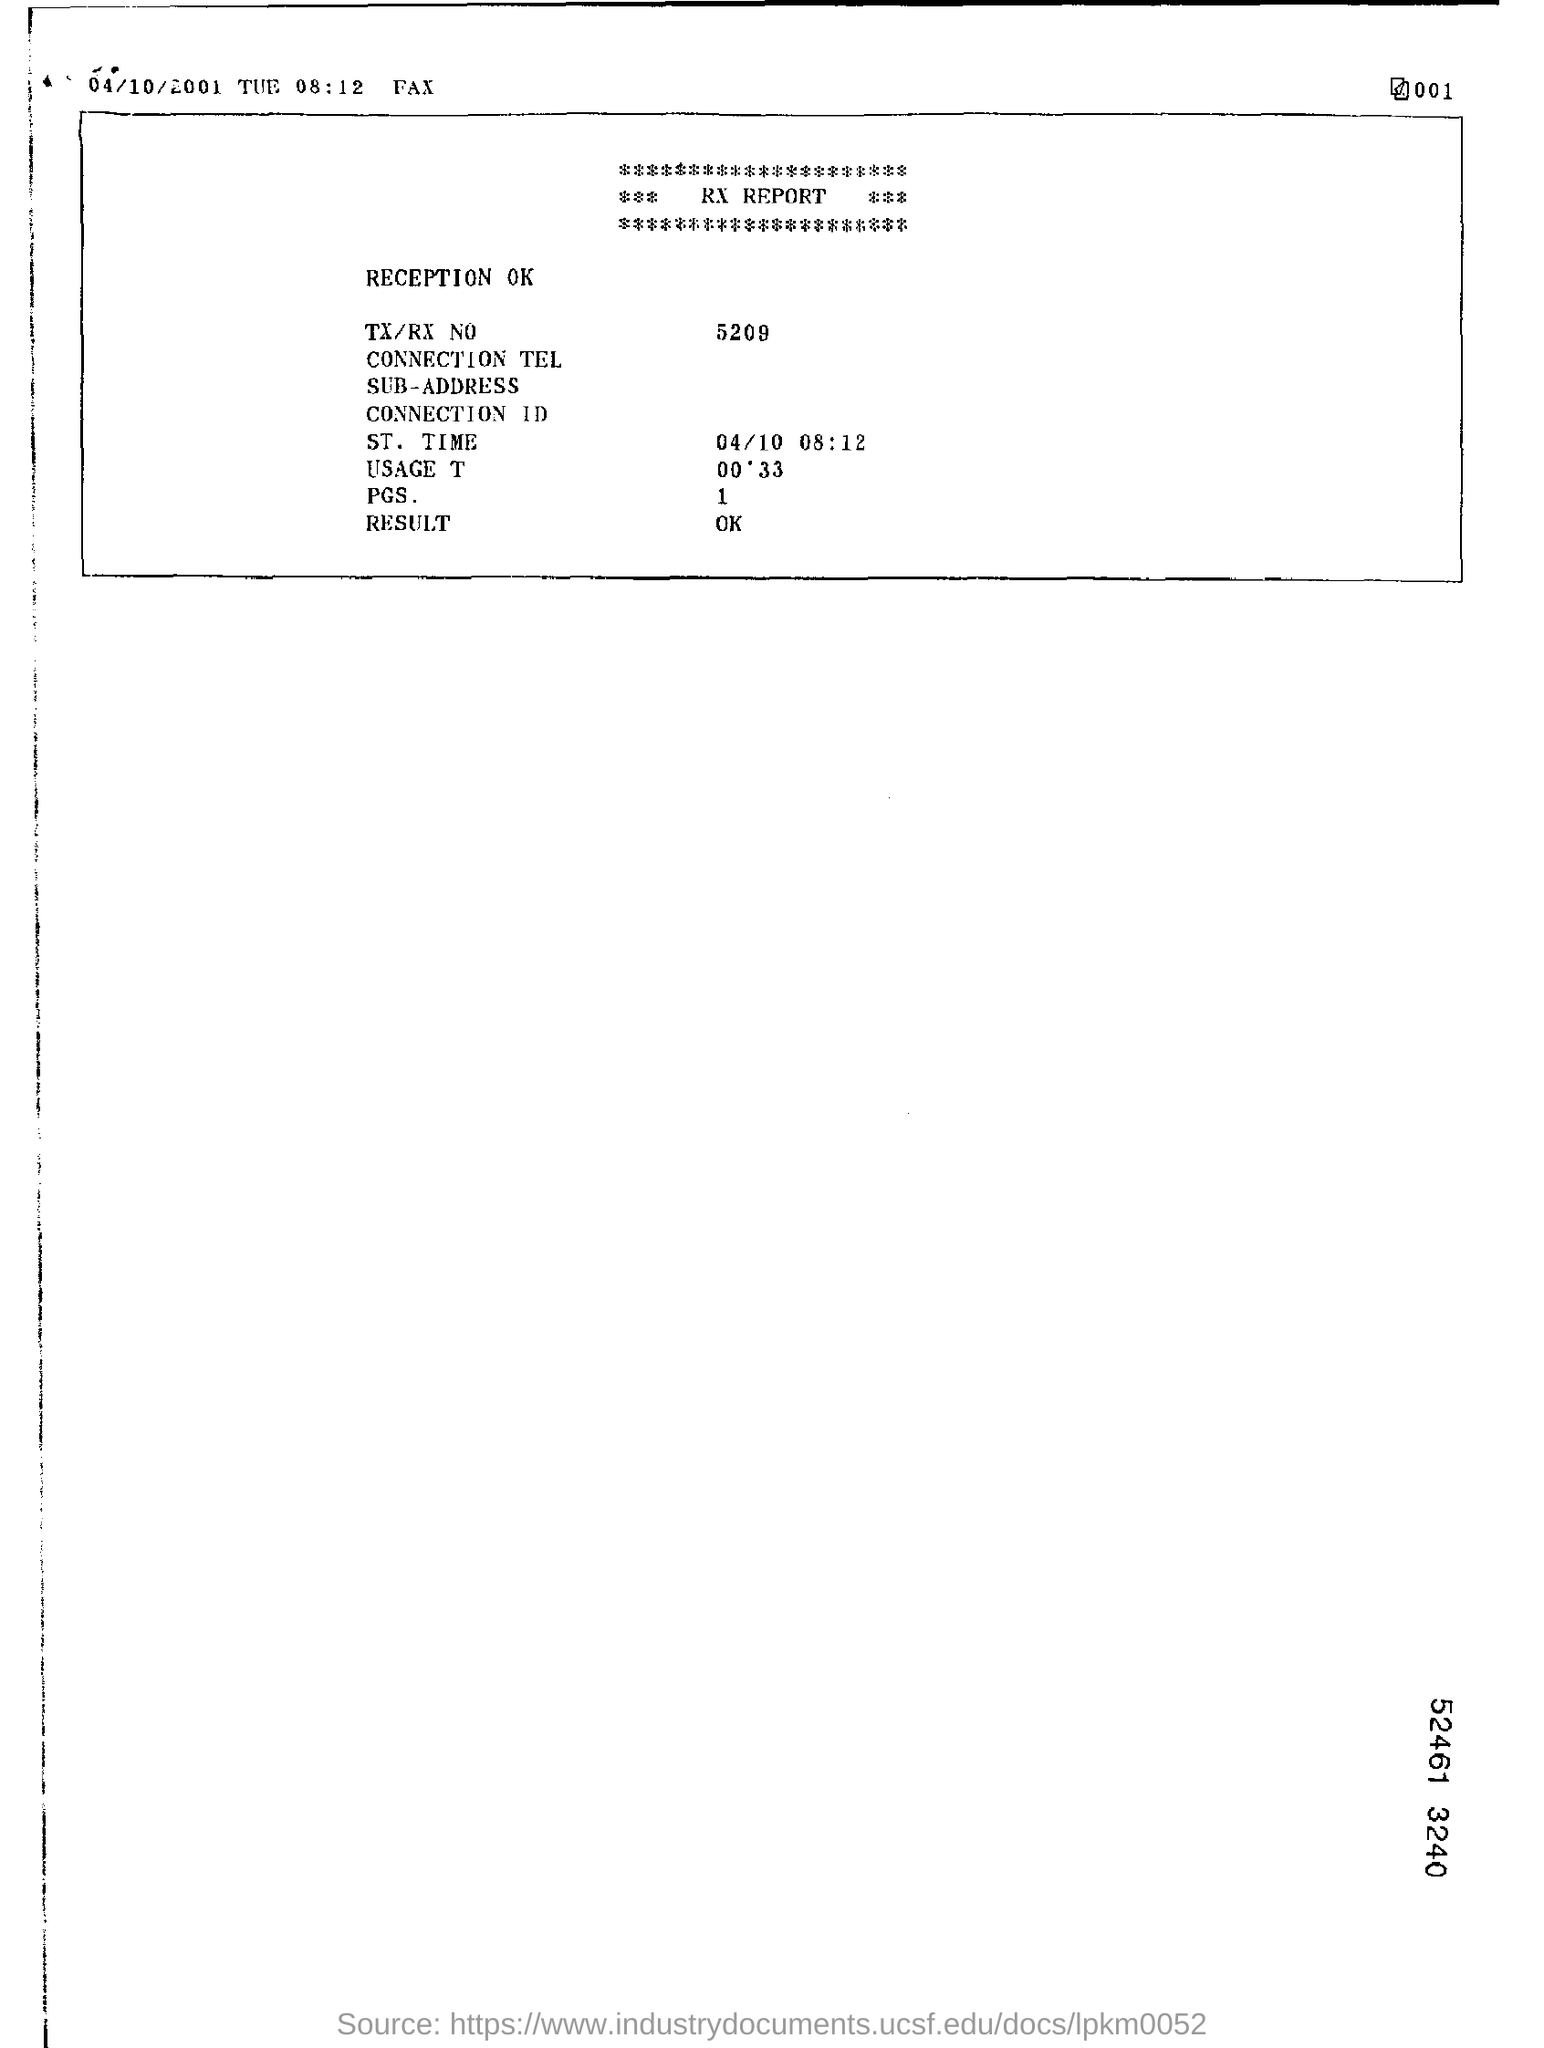What is the TX/RX No given in the RX Report?
Provide a short and direct response. 5209. What is the ST. Time mentioned in the RX Report?
Keep it short and to the point. 04/10  08:12. 